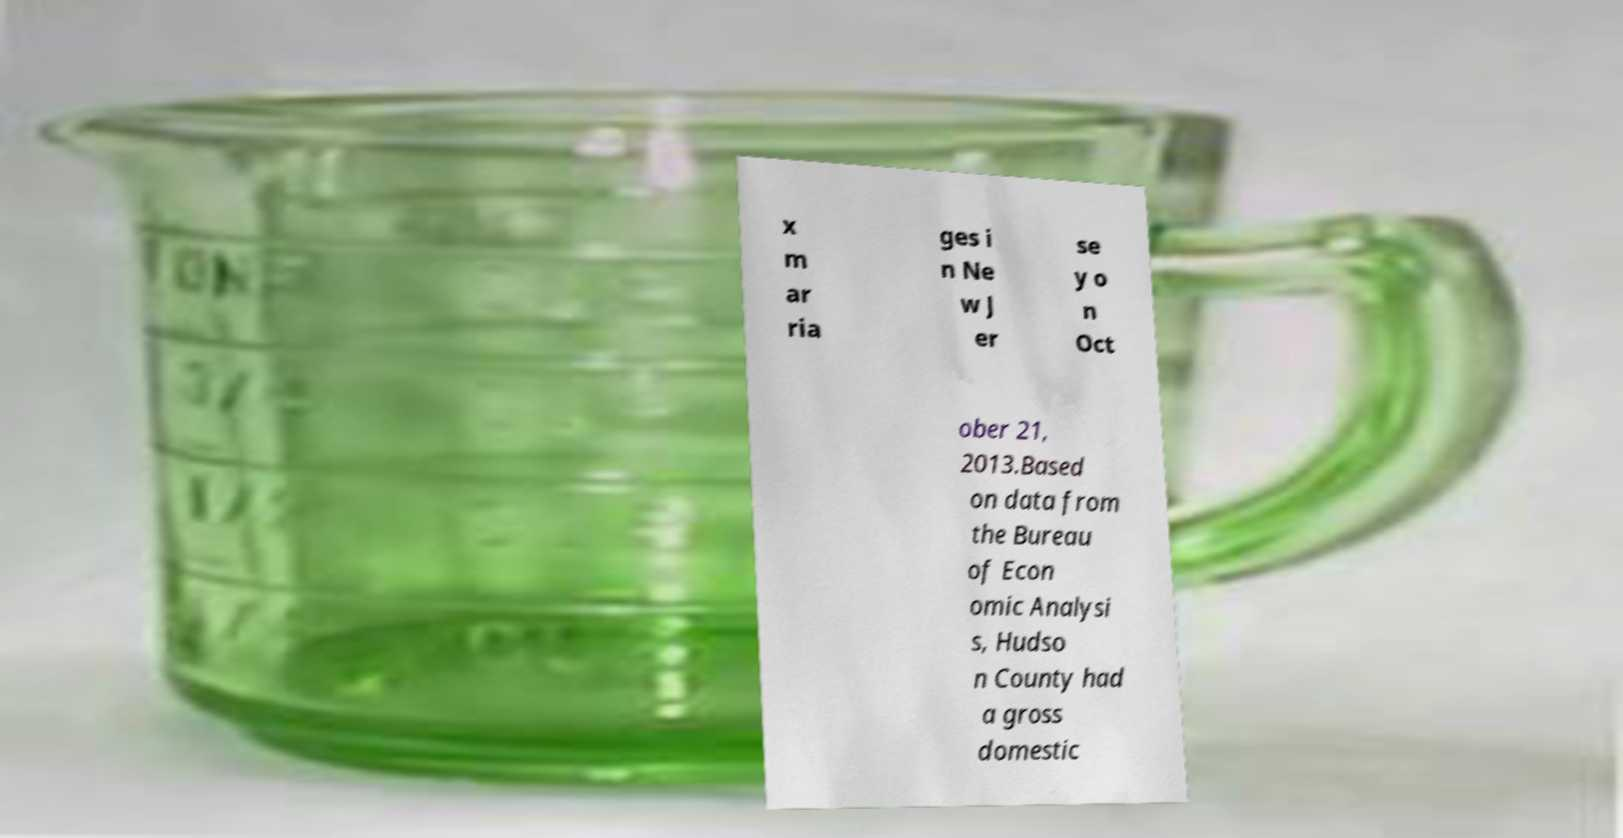Can you read and provide the text displayed in the image?This photo seems to have some interesting text. Can you extract and type it out for me? x m ar ria ges i n Ne w J er se y o n Oct ober 21, 2013.Based on data from the Bureau of Econ omic Analysi s, Hudso n County had a gross domestic 